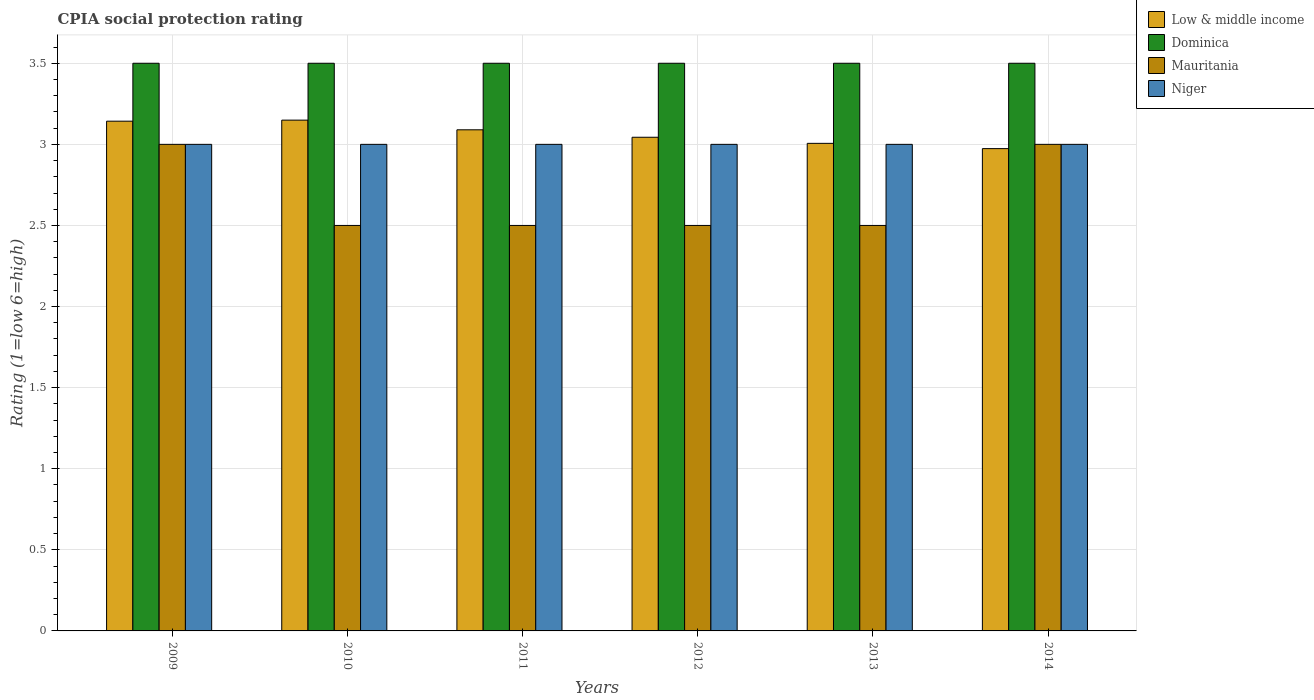Are the number of bars on each tick of the X-axis equal?
Your answer should be very brief. Yes. How many bars are there on the 1st tick from the right?
Your response must be concise. 4. What is the label of the 2nd group of bars from the left?
Your answer should be very brief. 2010. What is the CPIA rating in Dominica in 2010?
Make the answer very short. 3.5. Across all years, what is the maximum CPIA rating in Low & middle income?
Keep it short and to the point. 3.15. Across all years, what is the minimum CPIA rating in Dominica?
Provide a succinct answer. 3.5. In which year was the CPIA rating in Low & middle income maximum?
Your response must be concise. 2010. What is the difference between the CPIA rating in Niger in 2011 and that in 2014?
Keep it short and to the point. 0. What is the difference between the CPIA rating in Low & middle income in 2014 and the CPIA rating in Dominica in 2013?
Give a very brief answer. -0.53. What is the average CPIA rating in Low & middle income per year?
Your answer should be very brief. 3.07. In how many years, is the CPIA rating in Low & middle income greater than 3.2?
Provide a succinct answer. 0. What is the ratio of the CPIA rating in Mauritania in 2009 to that in 2013?
Your response must be concise. 1.2. Is the CPIA rating in Dominica in 2012 less than that in 2014?
Ensure brevity in your answer.  No. Is the difference between the CPIA rating in Niger in 2009 and 2011 greater than the difference between the CPIA rating in Mauritania in 2009 and 2011?
Your answer should be compact. No. What is the difference between the highest and the second highest CPIA rating in Low & middle income?
Make the answer very short. 0.01. Is it the case that in every year, the sum of the CPIA rating in Niger and CPIA rating in Dominica is greater than the sum of CPIA rating in Low & middle income and CPIA rating in Mauritania?
Your answer should be compact. Yes. What does the 4th bar from the right in 2014 represents?
Offer a very short reply. Low & middle income. How many bars are there?
Give a very brief answer. 24. Are all the bars in the graph horizontal?
Your response must be concise. No. What is the difference between two consecutive major ticks on the Y-axis?
Ensure brevity in your answer.  0.5. Are the values on the major ticks of Y-axis written in scientific E-notation?
Make the answer very short. No. Does the graph contain any zero values?
Ensure brevity in your answer.  No. How are the legend labels stacked?
Provide a short and direct response. Vertical. What is the title of the graph?
Your answer should be compact. CPIA social protection rating. What is the label or title of the X-axis?
Offer a terse response. Years. What is the Rating (1=low 6=high) of Low & middle income in 2009?
Make the answer very short. 3.14. What is the Rating (1=low 6=high) in Dominica in 2009?
Make the answer very short. 3.5. What is the Rating (1=low 6=high) in Mauritania in 2009?
Offer a terse response. 3. What is the Rating (1=low 6=high) in Low & middle income in 2010?
Your answer should be compact. 3.15. What is the Rating (1=low 6=high) in Mauritania in 2010?
Offer a terse response. 2.5. What is the Rating (1=low 6=high) of Niger in 2010?
Your response must be concise. 3. What is the Rating (1=low 6=high) of Low & middle income in 2011?
Offer a very short reply. 3.09. What is the Rating (1=low 6=high) of Dominica in 2011?
Your answer should be very brief. 3.5. What is the Rating (1=low 6=high) in Mauritania in 2011?
Provide a succinct answer. 2.5. What is the Rating (1=low 6=high) of Niger in 2011?
Your answer should be compact. 3. What is the Rating (1=low 6=high) of Low & middle income in 2012?
Provide a short and direct response. 3.04. What is the Rating (1=low 6=high) of Mauritania in 2012?
Your answer should be very brief. 2.5. What is the Rating (1=low 6=high) of Niger in 2012?
Your answer should be very brief. 3. What is the Rating (1=low 6=high) in Low & middle income in 2013?
Provide a succinct answer. 3.01. What is the Rating (1=low 6=high) of Dominica in 2013?
Your response must be concise. 3.5. What is the Rating (1=low 6=high) in Mauritania in 2013?
Ensure brevity in your answer.  2.5. What is the Rating (1=low 6=high) in Low & middle income in 2014?
Offer a terse response. 2.97. What is the Rating (1=low 6=high) of Dominica in 2014?
Ensure brevity in your answer.  3.5. Across all years, what is the maximum Rating (1=low 6=high) in Low & middle income?
Keep it short and to the point. 3.15. Across all years, what is the maximum Rating (1=low 6=high) of Mauritania?
Your answer should be compact. 3. Across all years, what is the minimum Rating (1=low 6=high) of Low & middle income?
Provide a succinct answer. 2.97. Across all years, what is the minimum Rating (1=low 6=high) of Mauritania?
Give a very brief answer. 2.5. Across all years, what is the minimum Rating (1=low 6=high) of Niger?
Offer a terse response. 3. What is the total Rating (1=low 6=high) in Low & middle income in the graph?
Offer a very short reply. 18.41. What is the difference between the Rating (1=low 6=high) in Low & middle income in 2009 and that in 2010?
Your answer should be very brief. -0.01. What is the difference between the Rating (1=low 6=high) in Niger in 2009 and that in 2010?
Keep it short and to the point. 0. What is the difference between the Rating (1=low 6=high) in Low & middle income in 2009 and that in 2011?
Your answer should be very brief. 0.05. What is the difference between the Rating (1=low 6=high) in Dominica in 2009 and that in 2011?
Offer a terse response. 0. What is the difference between the Rating (1=low 6=high) of Low & middle income in 2009 and that in 2012?
Your response must be concise. 0.1. What is the difference between the Rating (1=low 6=high) of Mauritania in 2009 and that in 2012?
Offer a terse response. 0.5. What is the difference between the Rating (1=low 6=high) in Niger in 2009 and that in 2012?
Your answer should be very brief. 0. What is the difference between the Rating (1=low 6=high) in Low & middle income in 2009 and that in 2013?
Your response must be concise. 0.14. What is the difference between the Rating (1=low 6=high) of Low & middle income in 2009 and that in 2014?
Your answer should be very brief. 0.17. What is the difference between the Rating (1=low 6=high) of Dominica in 2009 and that in 2014?
Offer a terse response. 0. What is the difference between the Rating (1=low 6=high) in Niger in 2009 and that in 2014?
Ensure brevity in your answer.  0. What is the difference between the Rating (1=low 6=high) of Low & middle income in 2010 and that in 2011?
Your answer should be compact. 0.06. What is the difference between the Rating (1=low 6=high) in Dominica in 2010 and that in 2011?
Keep it short and to the point. 0. What is the difference between the Rating (1=low 6=high) of Low & middle income in 2010 and that in 2012?
Your answer should be compact. 0.11. What is the difference between the Rating (1=low 6=high) in Dominica in 2010 and that in 2012?
Make the answer very short. 0. What is the difference between the Rating (1=low 6=high) in Mauritania in 2010 and that in 2012?
Your answer should be very brief. 0. What is the difference between the Rating (1=low 6=high) of Low & middle income in 2010 and that in 2013?
Make the answer very short. 0.14. What is the difference between the Rating (1=low 6=high) of Dominica in 2010 and that in 2013?
Offer a terse response. 0. What is the difference between the Rating (1=low 6=high) of Mauritania in 2010 and that in 2013?
Make the answer very short. 0. What is the difference between the Rating (1=low 6=high) of Low & middle income in 2010 and that in 2014?
Offer a very short reply. 0.18. What is the difference between the Rating (1=low 6=high) in Dominica in 2010 and that in 2014?
Provide a short and direct response. 0. What is the difference between the Rating (1=low 6=high) of Mauritania in 2010 and that in 2014?
Your response must be concise. -0.5. What is the difference between the Rating (1=low 6=high) of Low & middle income in 2011 and that in 2012?
Offer a very short reply. 0.05. What is the difference between the Rating (1=low 6=high) in Dominica in 2011 and that in 2012?
Your response must be concise. 0. What is the difference between the Rating (1=low 6=high) of Niger in 2011 and that in 2012?
Provide a short and direct response. 0. What is the difference between the Rating (1=low 6=high) of Low & middle income in 2011 and that in 2013?
Your answer should be compact. 0.08. What is the difference between the Rating (1=low 6=high) in Mauritania in 2011 and that in 2013?
Keep it short and to the point. 0. What is the difference between the Rating (1=low 6=high) in Low & middle income in 2011 and that in 2014?
Give a very brief answer. 0.12. What is the difference between the Rating (1=low 6=high) in Dominica in 2011 and that in 2014?
Give a very brief answer. 0. What is the difference between the Rating (1=low 6=high) of Low & middle income in 2012 and that in 2013?
Offer a very short reply. 0.04. What is the difference between the Rating (1=low 6=high) in Mauritania in 2012 and that in 2013?
Your answer should be compact. 0. What is the difference between the Rating (1=low 6=high) of Niger in 2012 and that in 2013?
Keep it short and to the point. 0. What is the difference between the Rating (1=low 6=high) of Low & middle income in 2012 and that in 2014?
Give a very brief answer. 0.07. What is the difference between the Rating (1=low 6=high) in Niger in 2012 and that in 2014?
Provide a succinct answer. 0. What is the difference between the Rating (1=low 6=high) of Low & middle income in 2013 and that in 2014?
Keep it short and to the point. 0.03. What is the difference between the Rating (1=low 6=high) of Dominica in 2013 and that in 2014?
Provide a short and direct response. 0. What is the difference between the Rating (1=low 6=high) of Niger in 2013 and that in 2014?
Provide a short and direct response. 0. What is the difference between the Rating (1=low 6=high) of Low & middle income in 2009 and the Rating (1=low 6=high) of Dominica in 2010?
Make the answer very short. -0.36. What is the difference between the Rating (1=low 6=high) in Low & middle income in 2009 and the Rating (1=low 6=high) in Mauritania in 2010?
Give a very brief answer. 0.64. What is the difference between the Rating (1=low 6=high) of Low & middle income in 2009 and the Rating (1=low 6=high) of Niger in 2010?
Ensure brevity in your answer.  0.14. What is the difference between the Rating (1=low 6=high) of Low & middle income in 2009 and the Rating (1=low 6=high) of Dominica in 2011?
Provide a short and direct response. -0.36. What is the difference between the Rating (1=low 6=high) in Low & middle income in 2009 and the Rating (1=low 6=high) in Mauritania in 2011?
Your response must be concise. 0.64. What is the difference between the Rating (1=low 6=high) of Low & middle income in 2009 and the Rating (1=low 6=high) of Niger in 2011?
Give a very brief answer. 0.14. What is the difference between the Rating (1=low 6=high) of Dominica in 2009 and the Rating (1=low 6=high) of Mauritania in 2011?
Offer a very short reply. 1. What is the difference between the Rating (1=low 6=high) of Low & middle income in 2009 and the Rating (1=low 6=high) of Dominica in 2012?
Offer a very short reply. -0.36. What is the difference between the Rating (1=low 6=high) of Low & middle income in 2009 and the Rating (1=low 6=high) of Mauritania in 2012?
Your answer should be compact. 0.64. What is the difference between the Rating (1=low 6=high) in Low & middle income in 2009 and the Rating (1=low 6=high) in Niger in 2012?
Your answer should be very brief. 0.14. What is the difference between the Rating (1=low 6=high) of Dominica in 2009 and the Rating (1=low 6=high) of Niger in 2012?
Ensure brevity in your answer.  0.5. What is the difference between the Rating (1=low 6=high) of Mauritania in 2009 and the Rating (1=low 6=high) of Niger in 2012?
Ensure brevity in your answer.  0. What is the difference between the Rating (1=low 6=high) of Low & middle income in 2009 and the Rating (1=low 6=high) of Dominica in 2013?
Your answer should be compact. -0.36. What is the difference between the Rating (1=low 6=high) in Low & middle income in 2009 and the Rating (1=low 6=high) in Mauritania in 2013?
Give a very brief answer. 0.64. What is the difference between the Rating (1=low 6=high) of Low & middle income in 2009 and the Rating (1=low 6=high) of Niger in 2013?
Provide a short and direct response. 0.14. What is the difference between the Rating (1=low 6=high) of Low & middle income in 2009 and the Rating (1=low 6=high) of Dominica in 2014?
Keep it short and to the point. -0.36. What is the difference between the Rating (1=low 6=high) in Low & middle income in 2009 and the Rating (1=low 6=high) in Mauritania in 2014?
Your response must be concise. 0.14. What is the difference between the Rating (1=low 6=high) in Low & middle income in 2009 and the Rating (1=low 6=high) in Niger in 2014?
Your answer should be very brief. 0.14. What is the difference between the Rating (1=low 6=high) of Mauritania in 2009 and the Rating (1=low 6=high) of Niger in 2014?
Your response must be concise. 0. What is the difference between the Rating (1=low 6=high) in Low & middle income in 2010 and the Rating (1=low 6=high) in Dominica in 2011?
Ensure brevity in your answer.  -0.35. What is the difference between the Rating (1=low 6=high) in Low & middle income in 2010 and the Rating (1=low 6=high) in Mauritania in 2011?
Ensure brevity in your answer.  0.65. What is the difference between the Rating (1=low 6=high) in Low & middle income in 2010 and the Rating (1=low 6=high) in Niger in 2011?
Give a very brief answer. 0.15. What is the difference between the Rating (1=low 6=high) of Dominica in 2010 and the Rating (1=low 6=high) of Mauritania in 2011?
Provide a short and direct response. 1. What is the difference between the Rating (1=low 6=high) of Low & middle income in 2010 and the Rating (1=low 6=high) of Dominica in 2012?
Offer a very short reply. -0.35. What is the difference between the Rating (1=low 6=high) in Low & middle income in 2010 and the Rating (1=low 6=high) in Mauritania in 2012?
Provide a succinct answer. 0.65. What is the difference between the Rating (1=low 6=high) in Low & middle income in 2010 and the Rating (1=low 6=high) in Niger in 2012?
Offer a very short reply. 0.15. What is the difference between the Rating (1=low 6=high) in Dominica in 2010 and the Rating (1=low 6=high) in Mauritania in 2012?
Give a very brief answer. 1. What is the difference between the Rating (1=low 6=high) of Low & middle income in 2010 and the Rating (1=low 6=high) of Dominica in 2013?
Keep it short and to the point. -0.35. What is the difference between the Rating (1=low 6=high) of Low & middle income in 2010 and the Rating (1=low 6=high) of Mauritania in 2013?
Provide a succinct answer. 0.65. What is the difference between the Rating (1=low 6=high) of Low & middle income in 2010 and the Rating (1=low 6=high) of Niger in 2013?
Give a very brief answer. 0.15. What is the difference between the Rating (1=low 6=high) in Dominica in 2010 and the Rating (1=low 6=high) in Mauritania in 2013?
Offer a terse response. 1. What is the difference between the Rating (1=low 6=high) of Dominica in 2010 and the Rating (1=low 6=high) of Niger in 2013?
Provide a short and direct response. 0.5. What is the difference between the Rating (1=low 6=high) of Mauritania in 2010 and the Rating (1=low 6=high) of Niger in 2013?
Ensure brevity in your answer.  -0.5. What is the difference between the Rating (1=low 6=high) in Low & middle income in 2010 and the Rating (1=low 6=high) in Dominica in 2014?
Your answer should be very brief. -0.35. What is the difference between the Rating (1=low 6=high) in Low & middle income in 2010 and the Rating (1=low 6=high) in Mauritania in 2014?
Provide a short and direct response. 0.15. What is the difference between the Rating (1=low 6=high) of Low & middle income in 2010 and the Rating (1=low 6=high) of Niger in 2014?
Your answer should be very brief. 0.15. What is the difference between the Rating (1=low 6=high) of Dominica in 2010 and the Rating (1=low 6=high) of Mauritania in 2014?
Give a very brief answer. 0.5. What is the difference between the Rating (1=low 6=high) of Dominica in 2010 and the Rating (1=low 6=high) of Niger in 2014?
Give a very brief answer. 0.5. What is the difference between the Rating (1=low 6=high) in Mauritania in 2010 and the Rating (1=low 6=high) in Niger in 2014?
Give a very brief answer. -0.5. What is the difference between the Rating (1=low 6=high) in Low & middle income in 2011 and the Rating (1=low 6=high) in Dominica in 2012?
Ensure brevity in your answer.  -0.41. What is the difference between the Rating (1=low 6=high) of Low & middle income in 2011 and the Rating (1=low 6=high) of Mauritania in 2012?
Make the answer very short. 0.59. What is the difference between the Rating (1=low 6=high) of Low & middle income in 2011 and the Rating (1=low 6=high) of Niger in 2012?
Give a very brief answer. 0.09. What is the difference between the Rating (1=low 6=high) in Mauritania in 2011 and the Rating (1=low 6=high) in Niger in 2012?
Give a very brief answer. -0.5. What is the difference between the Rating (1=low 6=high) of Low & middle income in 2011 and the Rating (1=low 6=high) of Dominica in 2013?
Ensure brevity in your answer.  -0.41. What is the difference between the Rating (1=low 6=high) in Low & middle income in 2011 and the Rating (1=low 6=high) in Mauritania in 2013?
Your answer should be very brief. 0.59. What is the difference between the Rating (1=low 6=high) of Low & middle income in 2011 and the Rating (1=low 6=high) of Niger in 2013?
Provide a succinct answer. 0.09. What is the difference between the Rating (1=low 6=high) in Dominica in 2011 and the Rating (1=low 6=high) in Mauritania in 2013?
Offer a very short reply. 1. What is the difference between the Rating (1=low 6=high) of Mauritania in 2011 and the Rating (1=low 6=high) of Niger in 2013?
Make the answer very short. -0.5. What is the difference between the Rating (1=low 6=high) in Low & middle income in 2011 and the Rating (1=low 6=high) in Dominica in 2014?
Your answer should be very brief. -0.41. What is the difference between the Rating (1=low 6=high) in Low & middle income in 2011 and the Rating (1=low 6=high) in Mauritania in 2014?
Your response must be concise. 0.09. What is the difference between the Rating (1=low 6=high) of Low & middle income in 2011 and the Rating (1=low 6=high) of Niger in 2014?
Your response must be concise. 0.09. What is the difference between the Rating (1=low 6=high) in Dominica in 2011 and the Rating (1=low 6=high) in Mauritania in 2014?
Make the answer very short. 0.5. What is the difference between the Rating (1=low 6=high) of Low & middle income in 2012 and the Rating (1=low 6=high) of Dominica in 2013?
Your answer should be very brief. -0.46. What is the difference between the Rating (1=low 6=high) in Low & middle income in 2012 and the Rating (1=low 6=high) in Mauritania in 2013?
Offer a very short reply. 0.54. What is the difference between the Rating (1=low 6=high) in Low & middle income in 2012 and the Rating (1=low 6=high) in Niger in 2013?
Make the answer very short. 0.04. What is the difference between the Rating (1=low 6=high) of Mauritania in 2012 and the Rating (1=low 6=high) of Niger in 2013?
Provide a short and direct response. -0.5. What is the difference between the Rating (1=low 6=high) in Low & middle income in 2012 and the Rating (1=low 6=high) in Dominica in 2014?
Your answer should be very brief. -0.46. What is the difference between the Rating (1=low 6=high) in Low & middle income in 2012 and the Rating (1=low 6=high) in Mauritania in 2014?
Offer a terse response. 0.04. What is the difference between the Rating (1=low 6=high) of Low & middle income in 2012 and the Rating (1=low 6=high) of Niger in 2014?
Ensure brevity in your answer.  0.04. What is the difference between the Rating (1=low 6=high) in Low & middle income in 2013 and the Rating (1=low 6=high) in Dominica in 2014?
Your response must be concise. -0.49. What is the difference between the Rating (1=low 6=high) of Low & middle income in 2013 and the Rating (1=low 6=high) of Mauritania in 2014?
Give a very brief answer. 0.01. What is the difference between the Rating (1=low 6=high) in Low & middle income in 2013 and the Rating (1=low 6=high) in Niger in 2014?
Give a very brief answer. 0.01. What is the difference between the Rating (1=low 6=high) in Dominica in 2013 and the Rating (1=low 6=high) in Mauritania in 2014?
Make the answer very short. 0.5. What is the difference between the Rating (1=low 6=high) of Dominica in 2013 and the Rating (1=low 6=high) of Niger in 2014?
Keep it short and to the point. 0.5. What is the average Rating (1=low 6=high) in Low & middle income per year?
Your answer should be very brief. 3.07. What is the average Rating (1=low 6=high) of Mauritania per year?
Make the answer very short. 2.67. What is the average Rating (1=low 6=high) in Niger per year?
Your answer should be very brief. 3. In the year 2009, what is the difference between the Rating (1=low 6=high) in Low & middle income and Rating (1=low 6=high) in Dominica?
Ensure brevity in your answer.  -0.36. In the year 2009, what is the difference between the Rating (1=low 6=high) in Low & middle income and Rating (1=low 6=high) in Mauritania?
Ensure brevity in your answer.  0.14. In the year 2009, what is the difference between the Rating (1=low 6=high) in Low & middle income and Rating (1=low 6=high) in Niger?
Your answer should be compact. 0.14. In the year 2009, what is the difference between the Rating (1=low 6=high) of Dominica and Rating (1=low 6=high) of Mauritania?
Your response must be concise. 0.5. In the year 2009, what is the difference between the Rating (1=low 6=high) in Mauritania and Rating (1=low 6=high) in Niger?
Provide a succinct answer. 0. In the year 2010, what is the difference between the Rating (1=low 6=high) of Low & middle income and Rating (1=low 6=high) of Dominica?
Offer a very short reply. -0.35. In the year 2010, what is the difference between the Rating (1=low 6=high) in Low & middle income and Rating (1=low 6=high) in Mauritania?
Provide a short and direct response. 0.65. In the year 2010, what is the difference between the Rating (1=low 6=high) in Low & middle income and Rating (1=low 6=high) in Niger?
Your answer should be very brief. 0.15. In the year 2010, what is the difference between the Rating (1=low 6=high) of Dominica and Rating (1=low 6=high) of Niger?
Your answer should be compact. 0.5. In the year 2010, what is the difference between the Rating (1=low 6=high) of Mauritania and Rating (1=low 6=high) of Niger?
Offer a very short reply. -0.5. In the year 2011, what is the difference between the Rating (1=low 6=high) in Low & middle income and Rating (1=low 6=high) in Dominica?
Provide a short and direct response. -0.41. In the year 2011, what is the difference between the Rating (1=low 6=high) in Low & middle income and Rating (1=low 6=high) in Mauritania?
Offer a terse response. 0.59. In the year 2011, what is the difference between the Rating (1=low 6=high) of Low & middle income and Rating (1=low 6=high) of Niger?
Your answer should be compact. 0.09. In the year 2012, what is the difference between the Rating (1=low 6=high) in Low & middle income and Rating (1=low 6=high) in Dominica?
Offer a terse response. -0.46. In the year 2012, what is the difference between the Rating (1=low 6=high) of Low & middle income and Rating (1=low 6=high) of Mauritania?
Your response must be concise. 0.54. In the year 2012, what is the difference between the Rating (1=low 6=high) of Low & middle income and Rating (1=low 6=high) of Niger?
Offer a terse response. 0.04. In the year 2013, what is the difference between the Rating (1=low 6=high) in Low & middle income and Rating (1=low 6=high) in Dominica?
Offer a very short reply. -0.49. In the year 2013, what is the difference between the Rating (1=low 6=high) of Low & middle income and Rating (1=low 6=high) of Mauritania?
Your answer should be compact. 0.51. In the year 2013, what is the difference between the Rating (1=low 6=high) of Low & middle income and Rating (1=low 6=high) of Niger?
Offer a terse response. 0.01. In the year 2013, what is the difference between the Rating (1=low 6=high) in Dominica and Rating (1=low 6=high) in Mauritania?
Provide a short and direct response. 1. In the year 2014, what is the difference between the Rating (1=low 6=high) in Low & middle income and Rating (1=low 6=high) in Dominica?
Offer a very short reply. -0.53. In the year 2014, what is the difference between the Rating (1=low 6=high) of Low & middle income and Rating (1=low 6=high) of Mauritania?
Ensure brevity in your answer.  -0.03. In the year 2014, what is the difference between the Rating (1=low 6=high) of Low & middle income and Rating (1=low 6=high) of Niger?
Provide a short and direct response. -0.03. In the year 2014, what is the difference between the Rating (1=low 6=high) of Dominica and Rating (1=low 6=high) of Niger?
Ensure brevity in your answer.  0.5. What is the ratio of the Rating (1=low 6=high) in Dominica in 2009 to that in 2010?
Provide a short and direct response. 1. What is the ratio of the Rating (1=low 6=high) of Niger in 2009 to that in 2010?
Your answer should be compact. 1. What is the ratio of the Rating (1=low 6=high) of Low & middle income in 2009 to that in 2011?
Provide a short and direct response. 1.02. What is the ratio of the Rating (1=low 6=high) of Dominica in 2009 to that in 2011?
Ensure brevity in your answer.  1. What is the ratio of the Rating (1=low 6=high) of Mauritania in 2009 to that in 2011?
Ensure brevity in your answer.  1.2. What is the ratio of the Rating (1=low 6=high) of Niger in 2009 to that in 2011?
Provide a succinct answer. 1. What is the ratio of the Rating (1=low 6=high) of Low & middle income in 2009 to that in 2012?
Your response must be concise. 1.03. What is the ratio of the Rating (1=low 6=high) of Dominica in 2009 to that in 2012?
Give a very brief answer. 1. What is the ratio of the Rating (1=low 6=high) of Niger in 2009 to that in 2012?
Offer a terse response. 1. What is the ratio of the Rating (1=low 6=high) in Low & middle income in 2009 to that in 2013?
Provide a short and direct response. 1.05. What is the ratio of the Rating (1=low 6=high) of Dominica in 2009 to that in 2013?
Your response must be concise. 1. What is the ratio of the Rating (1=low 6=high) of Mauritania in 2009 to that in 2013?
Your response must be concise. 1.2. What is the ratio of the Rating (1=low 6=high) in Niger in 2009 to that in 2013?
Your response must be concise. 1. What is the ratio of the Rating (1=low 6=high) in Low & middle income in 2009 to that in 2014?
Make the answer very short. 1.06. What is the ratio of the Rating (1=low 6=high) of Dominica in 2009 to that in 2014?
Make the answer very short. 1. What is the ratio of the Rating (1=low 6=high) in Niger in 2009 to that in 2014?
Your response must be concise. 1. What is the ratio of the Rating (1=low 6=high) of Low & middle income in 2010 to that in 2011?
Ensure brevity in your answer.  1.02. What is the ratio of the Rating (1=low 6=high) of Mauritania in 2010 to that in 2011?
Provide a short and direct response. 1. What is the ratio of the Rating (1=low 6=high) of Low & middle income in 2010 to that in 2012?
Ensure brevity in your answer.  1.03. What is the ratio of the Rating (1=low 6=high) of Niger in 2010 to that in 2012?
Provide a succinct answer. 1. What is the ratio of the Rating (1=low 6=high) in Low & middle income in 2010 to that in 2013?
Your response must be concise. 1.05. What is the ratio of the Rating (1=low 6=high) in Niger in 2010 to that in 2013?
Provide a short and direct response. 1. What is the ratio of the Rating (1=low 6=high) of Low & middle income in 2010 to that in 2014?
Ensure brevity in your answer.  1.06. What is the ratio of the Rating (1=low 6=high) of Low & middle income in 2011 to that in 2012?
Keep it short and to the point. 1.02. What is the ratio of the Rating (1=low 6=high) in Mauritania in 2011 to that in 2012?
Your answer should be very brief. 1. What is the ratio of the Rating (1=low 6=high) in Niger in 2011 to that in 2012?
Keep it short and to the point. 1. What is the ratio of the Rating (1=low 6=high) in Low & middle income in 2011 to that in 2013?
Give a very brief answer. 1.03. What is the ratio of the Rating (1=low 6=high) in Dominica in 2011 to that in 2013?
Your response must be concise. 1. What is the ratio of the Rating (1=low 6=high) of Mauritania in 2011 to that in 2013?
Your response must be concise. 1. What is the ratio of the Rating (1=low 6=high) of Niger in 2011 to that in 2013?
Keep it short and to the point. 1. What is the ratio of the Rating (1=low 6=high) in Low & middle income in 2011 to that in 2014?
Provide a succinct answer. 1.04. What is the ratio of the Rating (1=low 6=high) in Dominica in 2011 to that in 2014?
Your answer should be very brief. 1. What is the ratio of the Rating (1=low 6=high) of Mauritania in 2011 to that in 2014?
Offer a very short reply. 0.83. What is the ratio of the Rating (1=low 6=high) of Niger in 2011 to that in 2014?
Ensure brevity in your answer.  1. What is the ratio of the Rating (1=low 6=high) of Low & middle income in 2012 to that in 2013?
Offer a terse response. 1.01. What is the ratio of the Rating (1=low 6=high) in Dominica in 2012 to that in 2013?
Offer a terse response. 1. What is the ratio of the Rating (1=low 6=high) in Mauritania in 2012 to that in 2013?
Provide a succinct answer. 1. What is the ratio of the Rating (1=low 6=high) of Low & middle income in 2012 to that in 2014?
Keep it short and to the point. 1.02. What is the ratio of the Rating (1=low 6=high) of Dominica in 2012 to that in 2014?
Your answer should be compact. 1. What is the ratio of the Rating (1=low 6=high) in Niger in 2012 to that in 2014?
Ensure brevity in your answer.  1. What is the ratio of the Rating (1=low 6=high) of Low & middle income in 2013 to that in 2014?
Provide a short and direct response. 1.01. What is the ratio of the Rating (1=low 6=high) in Niger in 2013 to that in 2014?
Give a very brief answer. 1. What is the difference between the highest and the second highest Rating (1=low 6=high) of Low & middle income?
Ensure brevity in your answer.  0.01. What is the difference between the highest and the second highest Rating (1=low 6=high) of Mauritania?
Offer a very short reply. 0. What is the difference between the highest and the second highest Rating (1=low 6=high) of Niger?
Ensure brevity in your answer.  0. What is the difference between the highest and the lowest Rating (1=low 6=high) in Low & middle income?
Ensure brevity in your answer.  0.18. What is the difference between the highest and the lowest Rating (1=low 6=high) in Dominica?
Give a very brief answer. 0. What is the difference between the highest and the lowest Rating (1=low 6=high) in Mauritania?
Your response must be concise. 0.5. What is the difference between the highest and the lowest Rating (1=low 6=high) of Niger?
Your response must be concise. 0. 